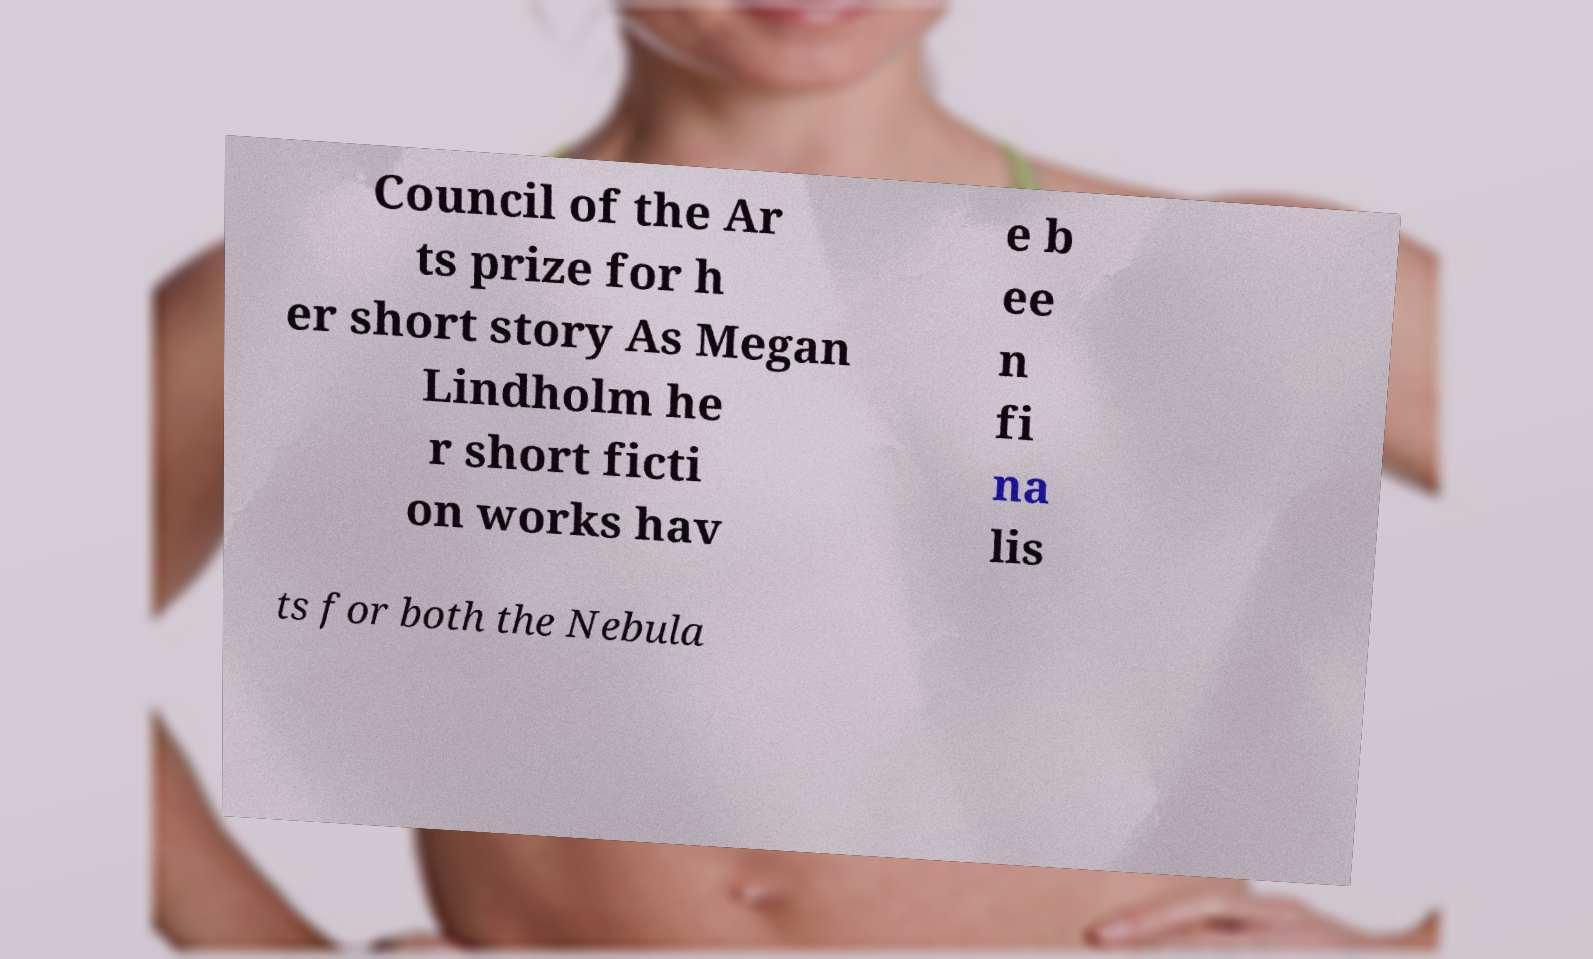Could you extract and type out the text from this image? Council of the Ar ts prize for h er short story As Megan Lindholm he r short ficti on works hav e b ee n fi na lis ts for both the Nebula 